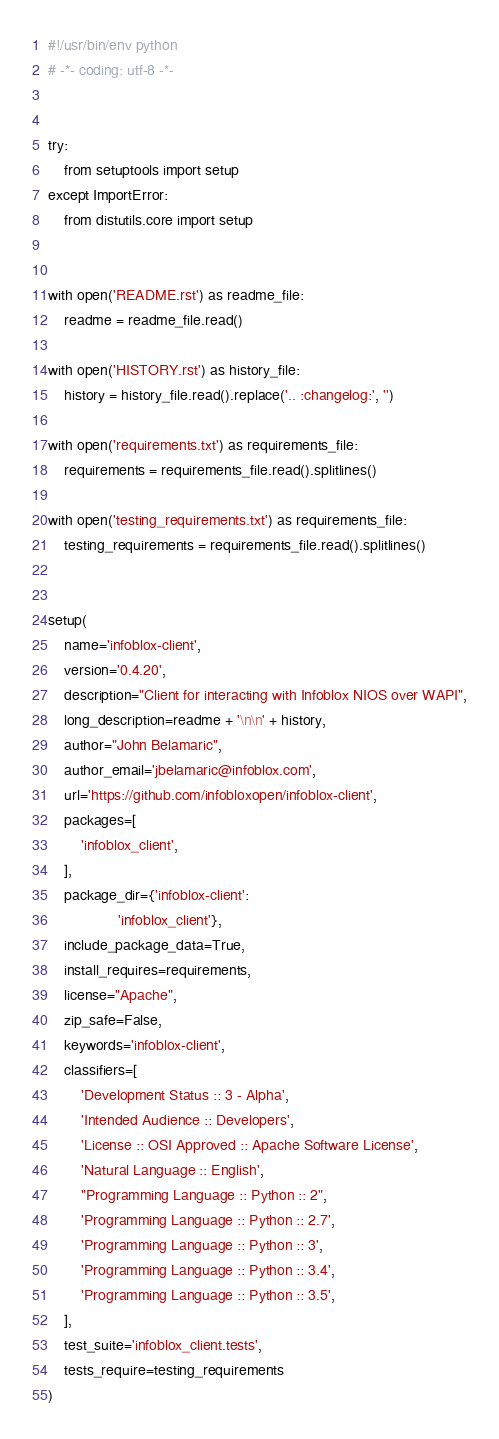Convert code to text. <code><loc_0><loc_0><loc_500><loc_500><_Python_>#!/usr/bin/env python
# -*- coding: utf-8 -*-


try:
    from setuptools import setup
except ImportError:
    from distutils.core import setup


with open('README.rst') as readme_file:
    readme = readme_file.read()

with open('HISTORY.rst') as history_file:
    history = history_file.read().replace('.. :changelog:', '')

with open('requirements.txt') as requirements_file:
    requirements = requirements_file.read().splitlines()

with open('testing_requirements.txt') as requirements_file:
    testing_requirements = requirements_file.read().splitlines()


setup(
    name='infoblox-client',
    version='0.4.20',
    description="Client for interacting with Infoblox NIOS over WAPI",
    long_description=readme + '\n\n' + history,
    author="John Belamaric",
    author_email='jbelamaric@infoblox.com',
    url='https://github.com/infobloxopen/infoblox-client',
    packages=[
        'infoblox_client',
    ],
    package_dir={'infoblox-client':
                 'infoblox_client'},
    include_package_data=True,
    install_requires=requirements,
    license="Apache",
    zip_safe=False,
    keywords='infoblox-client',
    classifiers=[
        'Development Status :: 3 - Alpha',
        'Intended Audience :: Developers',
        'License :: OSI Approved :: Apache Software License',
        'Natural Language :: English',
        "Programming Language :: Python :: 2",
        'Programming Language :: Python :: 2.7',
        'Programming Language :: Python :: 3',
        'Programming Language :: Python :: 3.4',
        'Programming Language :: Python :: 3.5',
    ],
    test_suite='infoblox_client.tests',
    tests_require=testing_requirements
)
</code> 